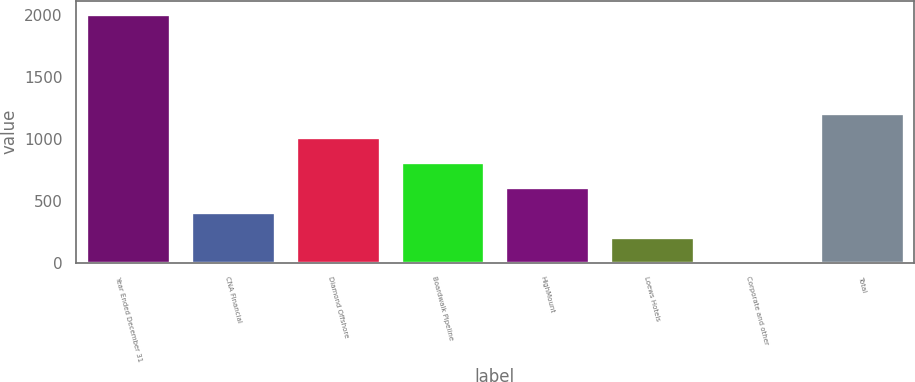Convert chart. <chart><loc_0><loc_0><loc_500><loc_500><bar_chart><fcel>Year Ended December 31<fcel>CNA Financial<fcel>Diamond Offshore<fcel>Boardwalk Pipeline<fcel>HighMount<fcel>Loews Hotels<fcel>Corporate and other<fcel>Total<nl><fcel>2011<fcel>410.2<fcel>1010.5<fcel>810.4<fcel>610.3<fcel>210.1<fcel>10<fcel>1210.6<nl></chart> 